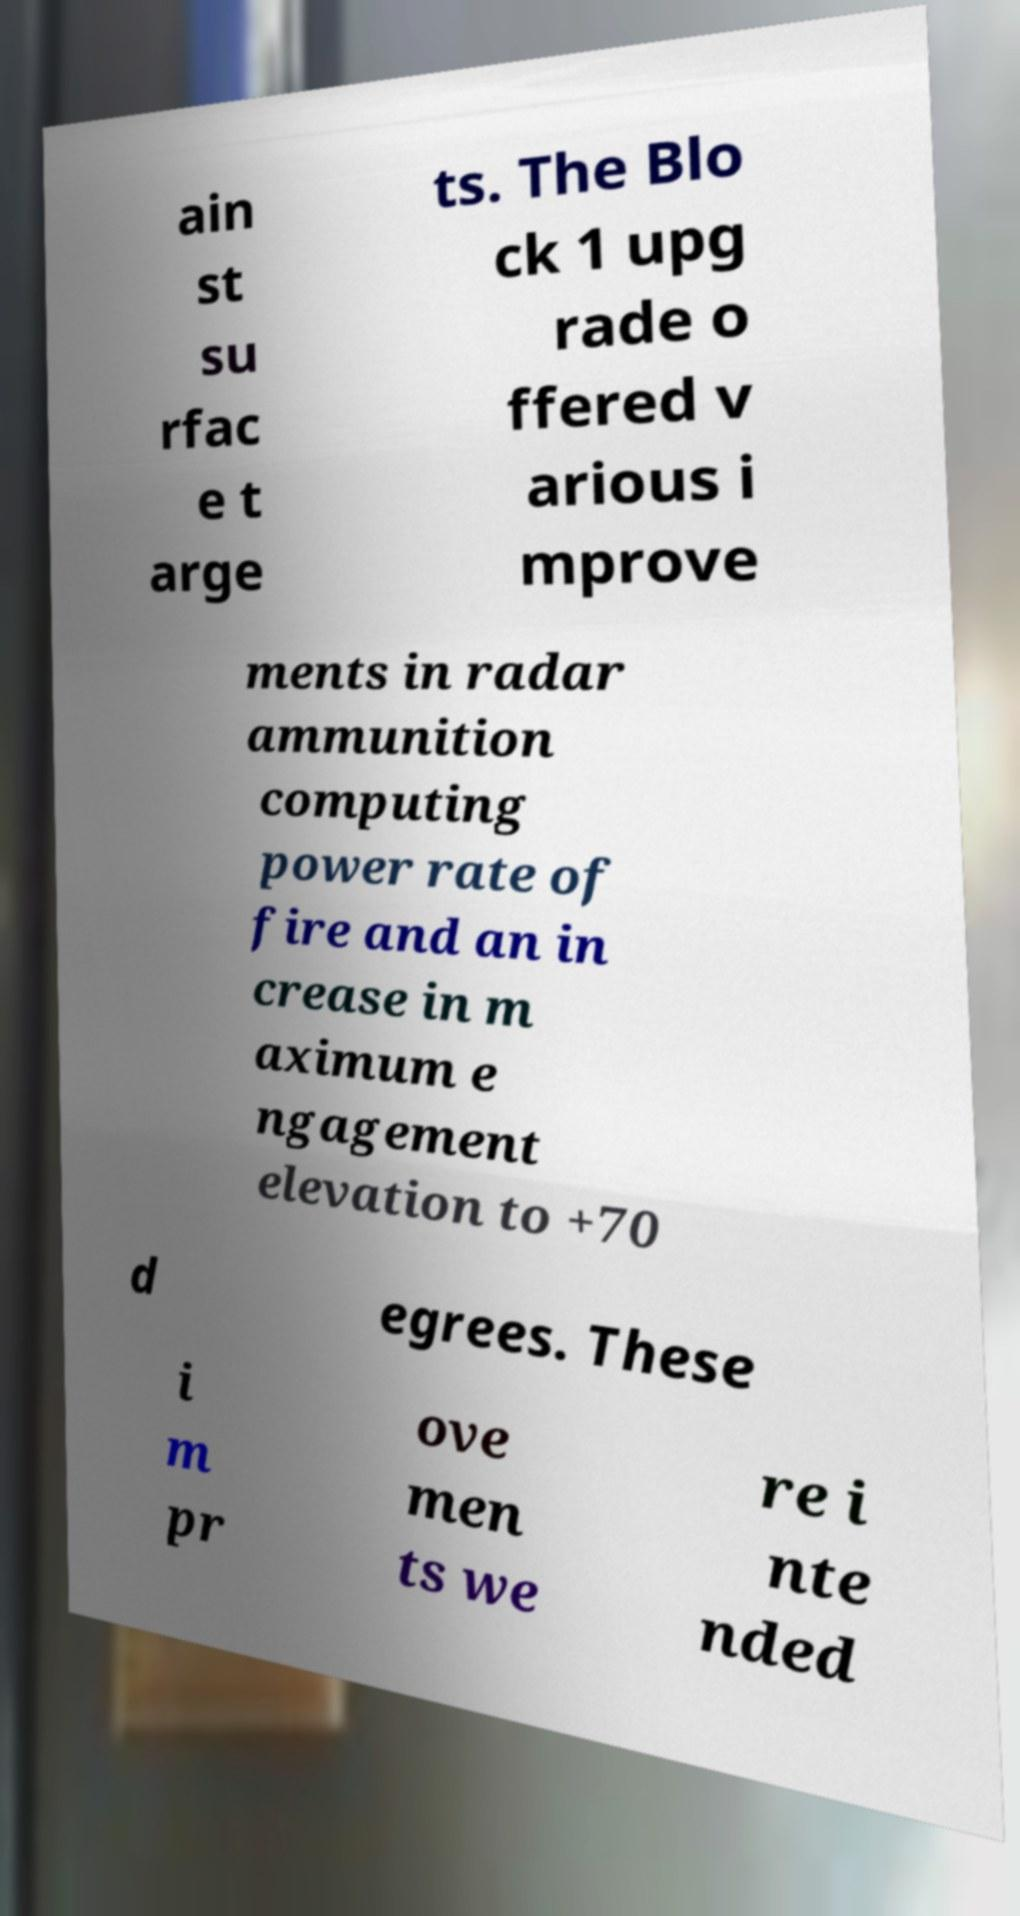I need the written content from this picture converted into text. Can you do that? ain st su rfac e t arge ts. The Blo ck 1 upg rade o ffered v arious i mprove ments in radar ammunition computing power rate of fire and an in crease in m aximum e ngagement elevation to +70 d egrees. These i m pr ove men ts we re i nte nded 